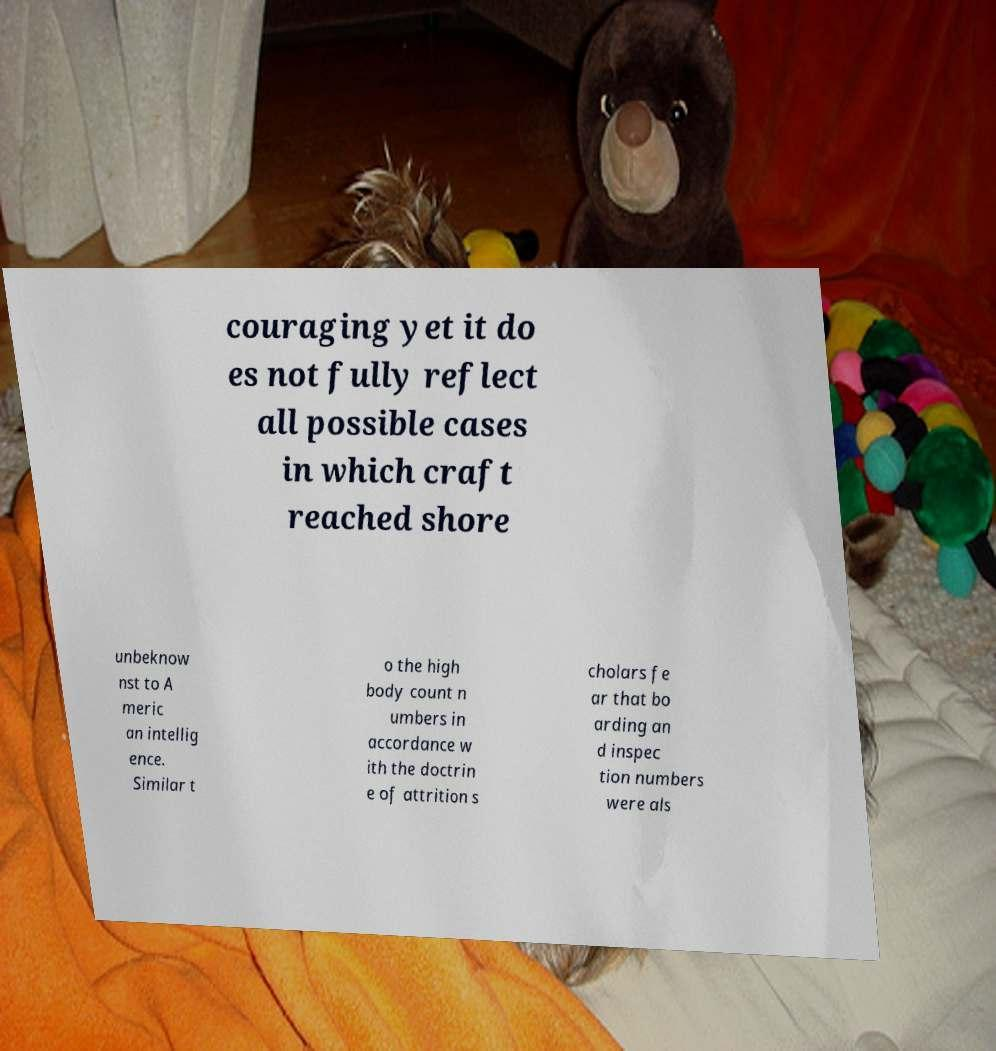Could you extract and type out the text from this image? couraging yet it do es not fully reflect all possible cases in which craft reached shore unbeknow nst to A meric an intellig ence. Similar t o the high body count n umbers in accordance w ith the doctrin e of attrition s cholars fe ar that bo arding an d inspec tion numbers were als 